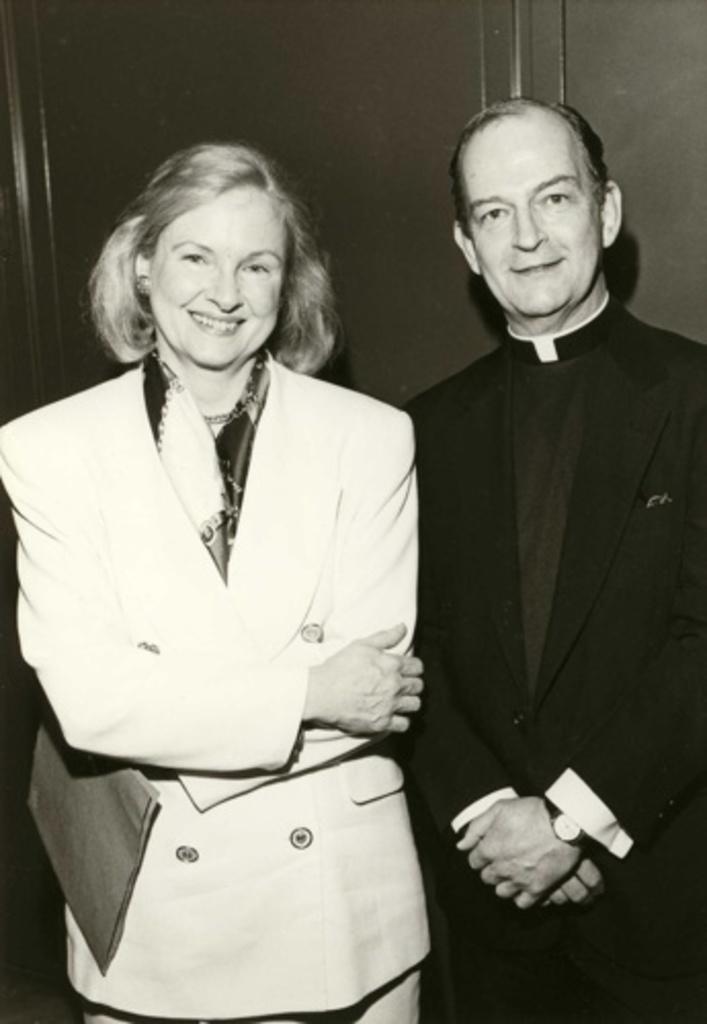Please provide a concise description of this image. This is a black and white image. In this image there is a lady holding something in the hand. There is a man wearing watch. In the back there is a wall. 